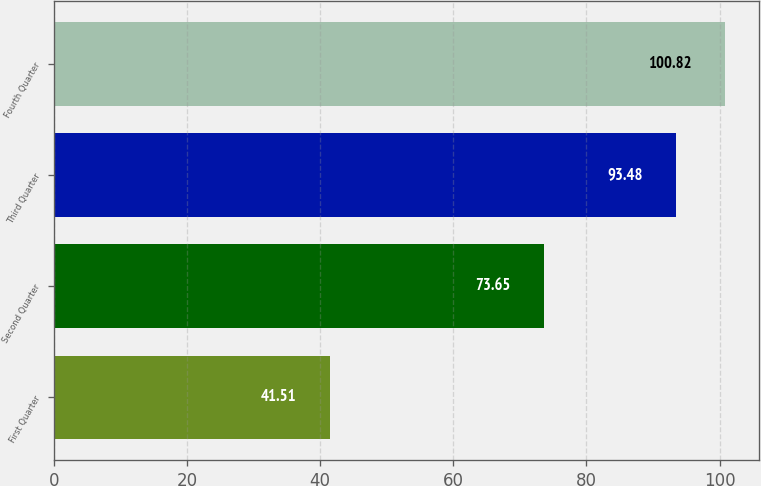Convert chart to OTSL. <chart><loc_0><loc_0><loc_500><loc_500><bar_chart><fcel>First Quarter<fcel>Second Quarter<fcel>Third Quarter<fcel>Fourth Quarter<nl><fcel>41.51<fcel>73.65<fcel>93.48<fcel>100.82<nl></chart> 